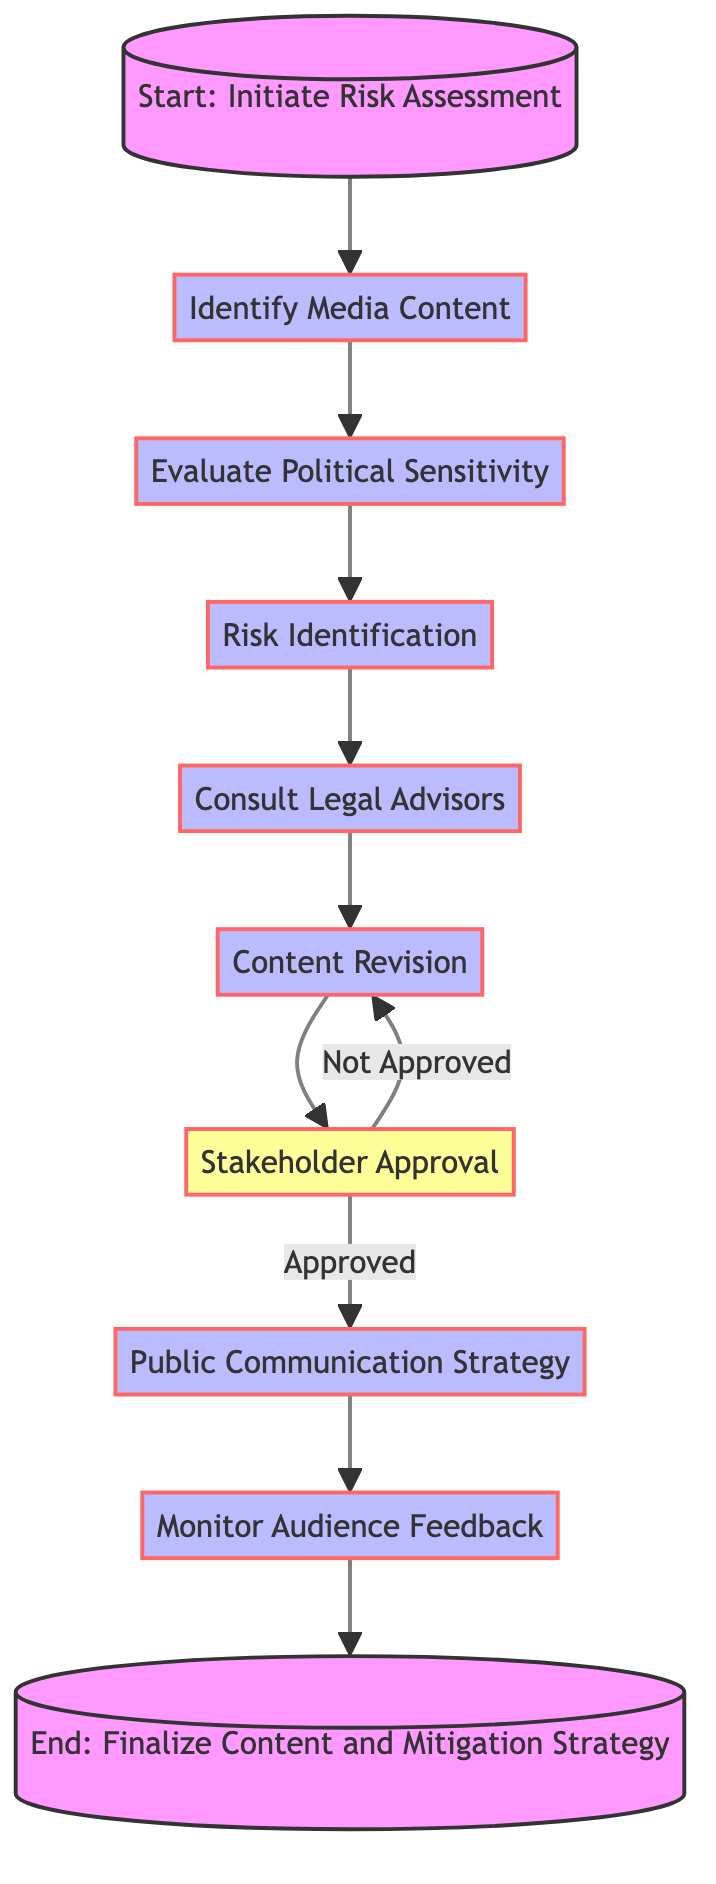What is the starting point of the flowchart? The flowchart begins at the node labeled "Start: Initiate Risk Assessment," which indicates the first step in the process of identifying and mitigating media sensitivity risks.
Answer: Start: Initiate Risk Assessment How many steps are there in the process? The flowchart contains a total of eight steps that detail the process of identifying and mitigating media sensitivity risks, from the initial start point to the end.
Answer: Eight What are the actions involved in "Evaluate Political Sensitivity"? The actions listed under "Evaluate Political Sensitivity" include consulting current UK-Russia political relations, engaging with political advisors, and monitoring media coverage and public sentiment.
Answer: Consult current UK-Russia political relations, engage with political advisors, monitor media coverage and public sentiment What happens if the "Stakeholder Approval" is not granted? If "Stakeholder Approval" is not granted, the flowchart indicates that it loops back to "Content Revision," indicating that the content will need to be revised again before resubmission for approval.
Answer: Content Revision What are the two options that follow "Stakeholder Approval"? After the "Stakeholder Approval" step, the flowchart decides either to proceed with the "Public Communication Strategy" if approved or to return to "Content Revision" if not approved.
Answer: Public Communication Strategy or Content Revision What comes after "Monitor Audience Feedback"? Following "Monitor Audience Feedback," the next step is to finalize the content and mitigation strategy, completing the process outlined in the flowchart.
Answer: Finalize Content and Mitigation Strategy Which action involves consulting external experts? The action that involves consulting external experts is labeled "Consult Legal Advisors," where a legal review for compliance and expert opinions on sensitive content are obtained.
Answer: Consult Legal Advisors What feedback is analyzed in the "Monitor Audience Feedback" step? In the "Monitor Audience Feedback" step, initial reactions to the content are analyzed, which helps in adjusting communication strategies as needed.
Answer: Initial reactions to the content 